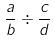Convert formula to latex. <formula><loc_0><loc_0><loc_500><loc_500>\frac { a } { b } \div \frac { c } { d }</formula> 